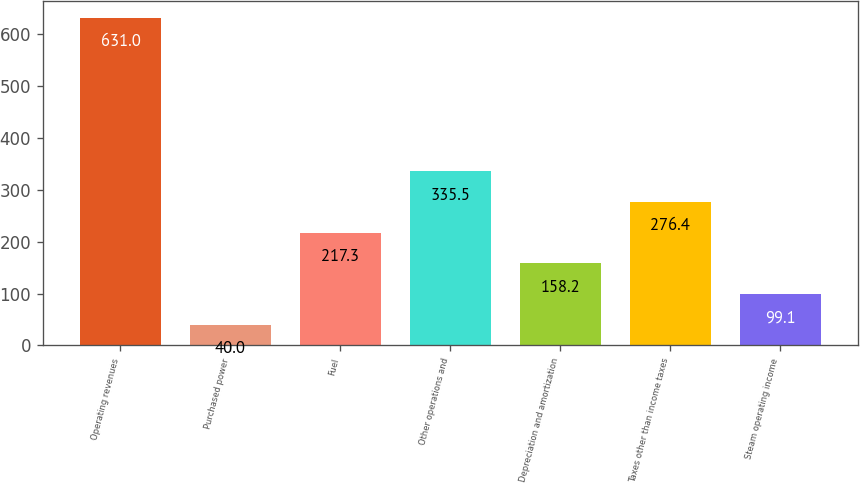<chart> <loc_0><loc_0><loc_500><loc_500><bar_chart><fcel>Operating revenues<fcel>Purchased power<fcel>Fuel<fcel>Other operations and<fcel>Depreciation and amortization<fcel>Taxes other than income taxes<fcel>Steam operating income<nl><fcel>631<fcel>40<fcel>217.3<fcel>335.5<fcel>158.2<fcel>276.4<fcel>99.1<nl></chart> 